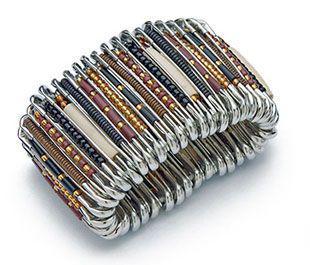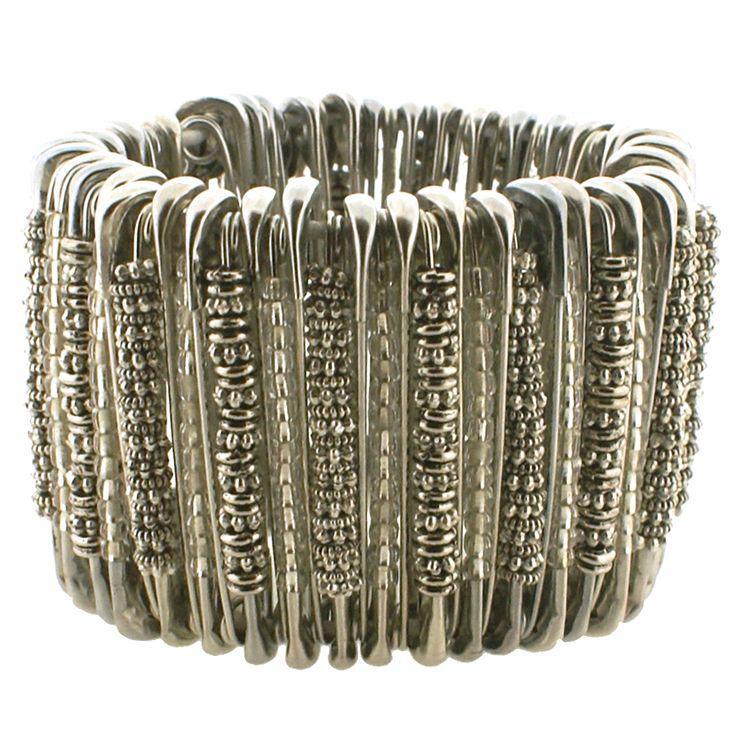The first image is the image on the left, the second image is the image on the right. Assess this claim about the two images: "In one image, a bracelet made out of safety pins and blue and silver beads is on the arm of a person.". Correct or not? Answer yes or no. No. The first image is the image on the left, the second image is the image on the right. For the images shown, is this caption "A bracelet is worn by a person." true? Answer yes or no. No. 